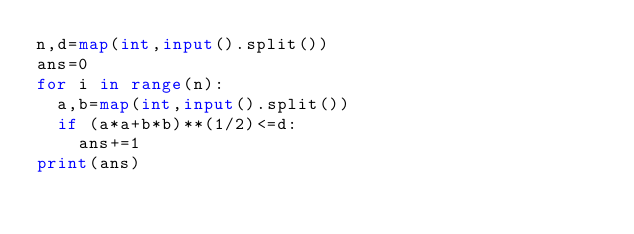<code> <loc_0><loc_0><loc_500><loc_500><_Python_>n,d=map(int,input().split())
ans=0
for i in range(n):
  a,b=map(int,input().split())
  if (a*a+b*b)**(1/2)<=d:
    ans+=1
print(ans)</code> 